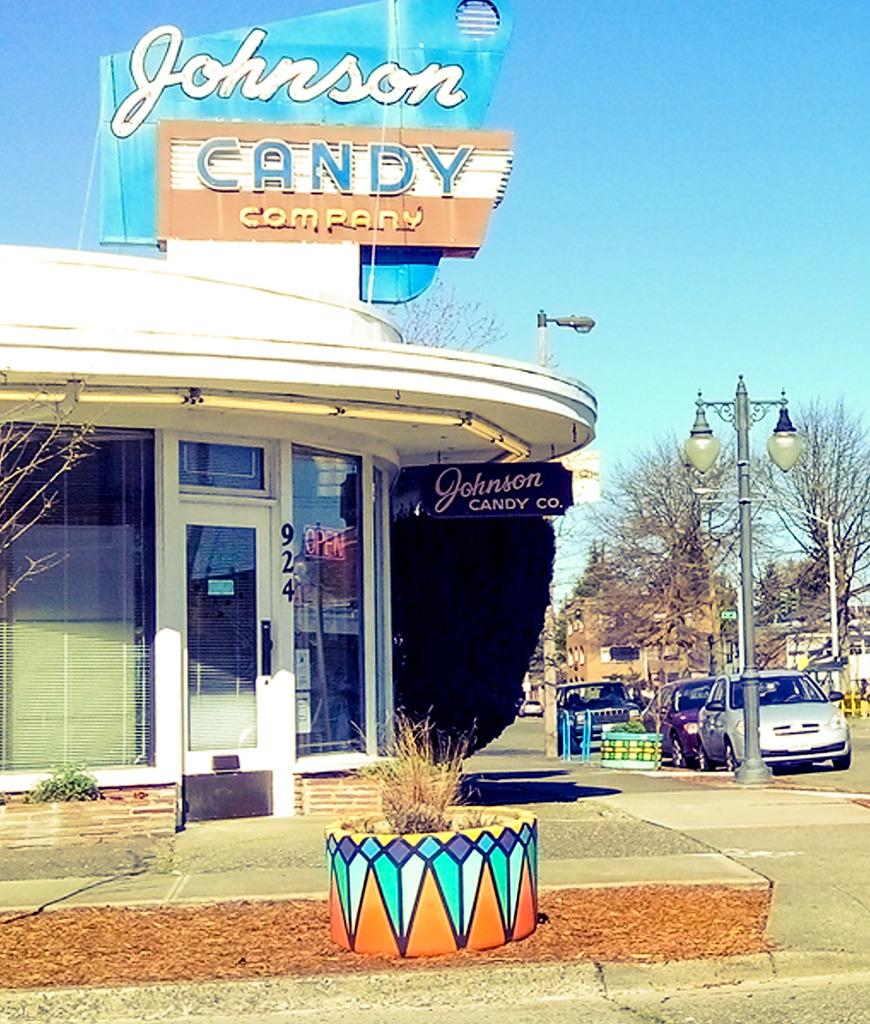What type of establishment is visible in the image? There is a store in the image. Can you describe any text or writing above the store? Yes, there is text or writing above the store. What else can be seen in the image besides the store? There are vehicles, trees, and a street light in the image. Where is the street light located in the image? The street light is in the right corner of the image. What type of iron or gold is present in the image? There is no iron or gold present in the image. Can you describe the hand gestures of the people in the image? There are no people visible in the image, so hand gestures cannot be described. 